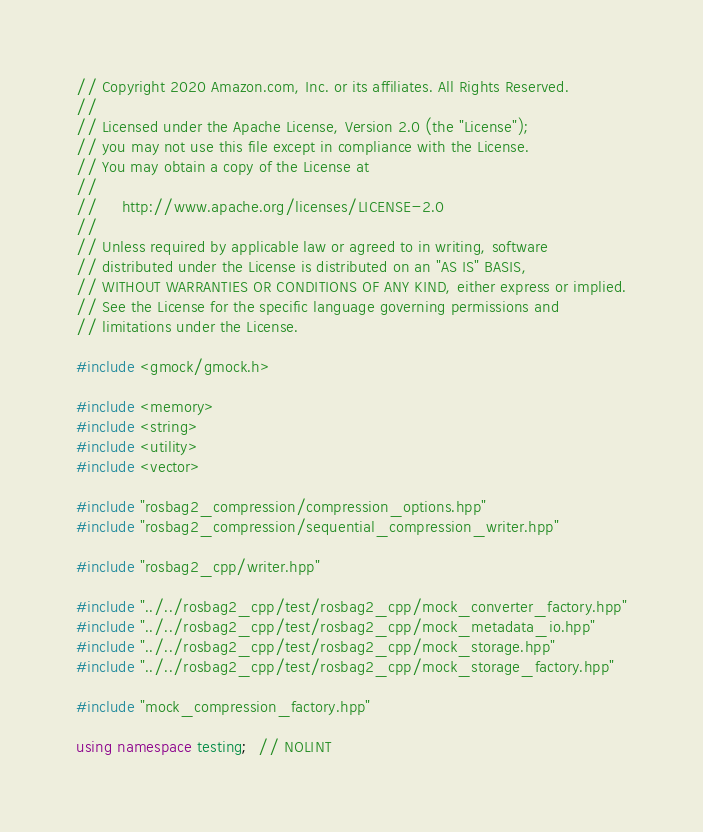Convert code to text. <code><loc_0><loc_0><loc_500><loc_500><_C++_>// Copyright 2020 Amazon.com, Inc. or its affiliates. All Rights Reserved.
//
// Licensed under the Apache License, Version 2.0 (the "License");
// you may not use this file except in compliance with the License.
// You may obtain a copy of the License at
//
//     http://www.apache.org/licenses/LICENSE-2.0
//
// Unless required by applicable law or agreed to in writing, software
// distributed under the License is distributed on an "AS IS" BASIS,
// WITHOUT WARRANTIES OR CONDITIONS OF ANY KIND, either express or implied.
// See the License for the specific language governing permissions and
// limitations under the License.

#include <gmock/gmock.h>

#include <memory>
#include <string>
#include <utility>
#include <vector>

#include "rosbag2_compression/compression_options.hpp"
#include "rosbag2_compression/sequential_compression_writer.hpp"

#include "rosbag2_cpp/writer.hpp"

#include "../../rosbag2_cpp/test/rosbag2_cpp/mock_converter_factory.hpp"
#include "../../rosbag2_cpp/test/rosbag2_cpp/mock_metadata_io.hpp"
#include "../../rosbag2_cpp/test/rosbag2_cpp/mock_storage.hpp"
#include "../../rosbag2_cpp/test/rosbag2_cpp/mock_storage_factory.hpp"

#include "mock_compression_factory.hpp"

using namespace testing;  // NOLINT
</code> 